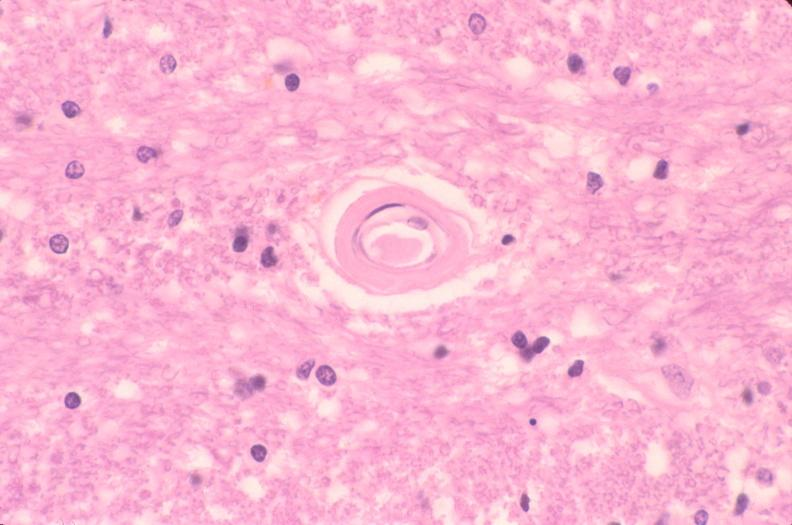where is this?
Answer the question using a single word or phrase. Nervous 